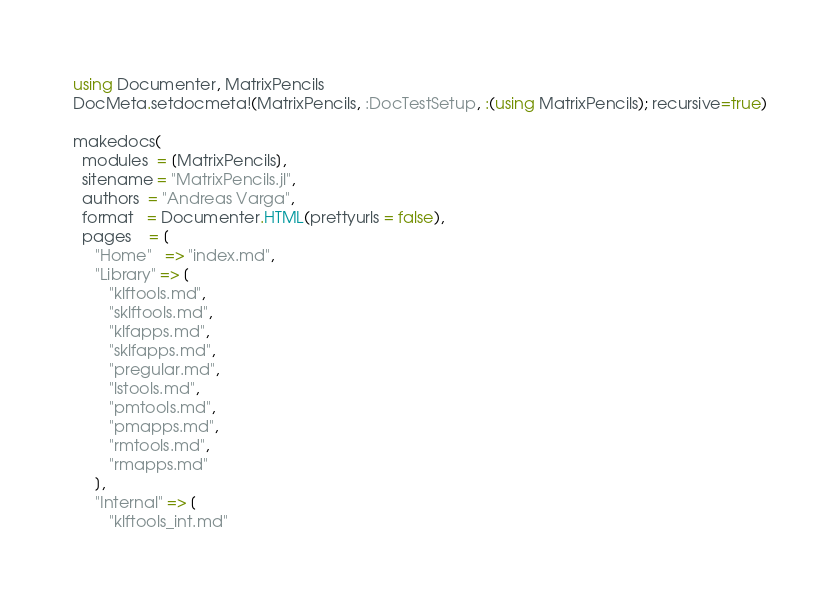Convert code to text. <code><loc_0><loc_0><loc_500><loc_500><_Julia_>using Documenter, MatrixPencils
DocMeta.setdocmeta!(MatrixPencils, :DocTestSetup, :(using MatrixPencils); recursive=true)

makedocs(
  modules  = [MatrixPencils],
  sitename = "MatrixPencils.jl",
  authors  = "Andreas Varga",
  format   = Documenter.HTML(prettyurls = false),
  pages    = [
     "Home"   => "index.md",
     "Library" => [ 
        "klftools.md",
        "sklftools.md",
        "klfapps.md",
        "sklfapps.md",
        "pregular.md",
        "lstools.md",
        "pmtools.md",
        "pmapps.md",
        "rmtools.md",
        "rmapps.md"
     ],
     "Internal" => [
        "klftools_int.md"</code> 